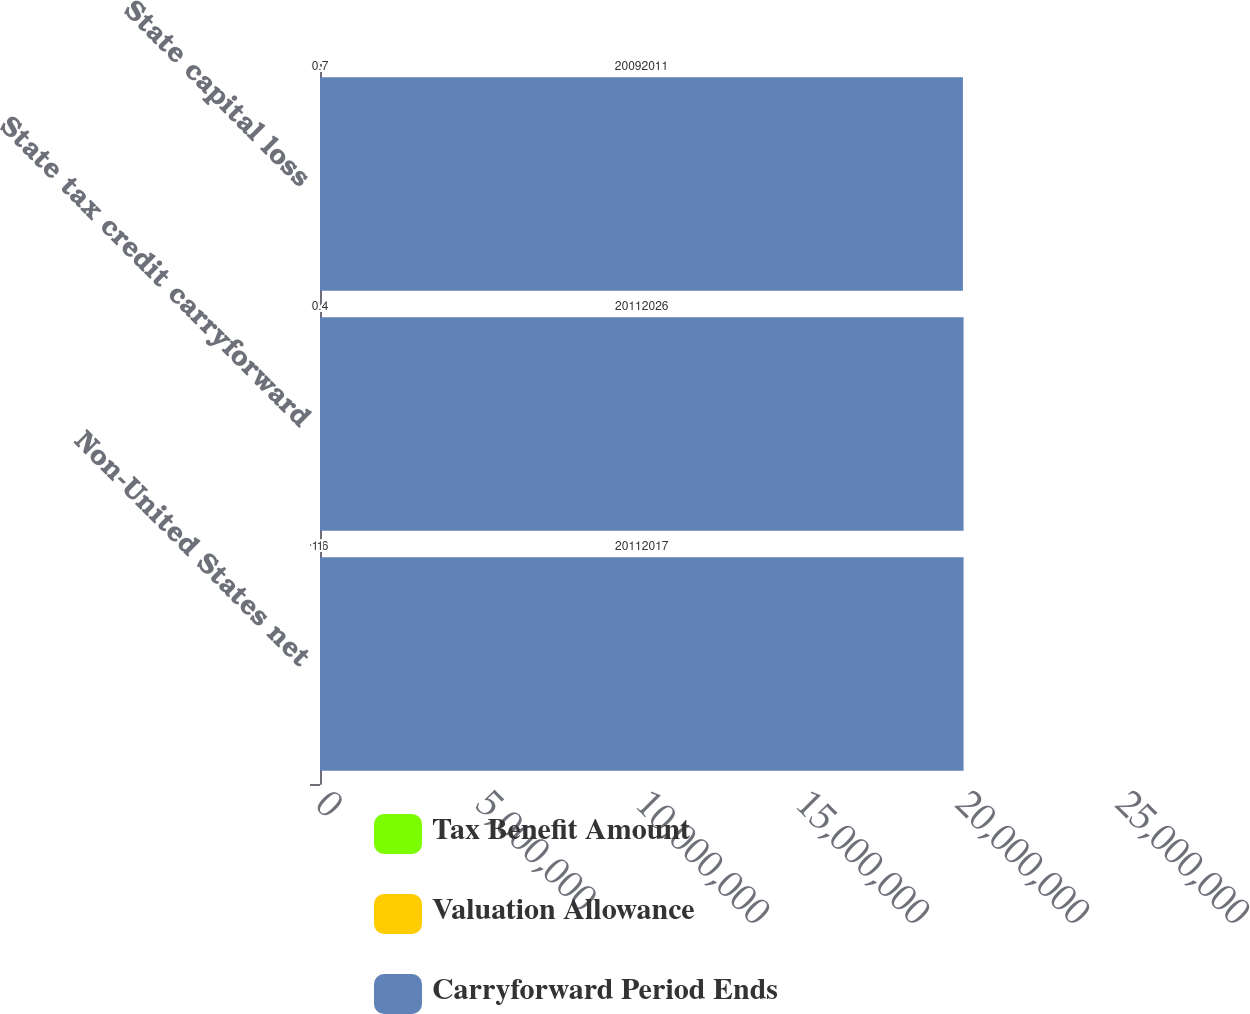Convert chart to OTSL. <chart><loc_0><loc_0><loc_500><loc_500><stacked_bar_chart><ecel><fcel>Non-United States net<fcel>State tax credit carryforward<fcel>State capital loss<nl><fcel>Tax Benefit Amount<fcel>1.6<fcel>6.4<fcel>0.7<nl><fcel>Valuation Allowance<fcel>1<fcel>0.4<fcel>0.7<nl><fcel>Carryforward Period Ends<fcel>2.0112e+07<fcel>2.0112e+07<fcel>2.0092e+07<nl></chart> 